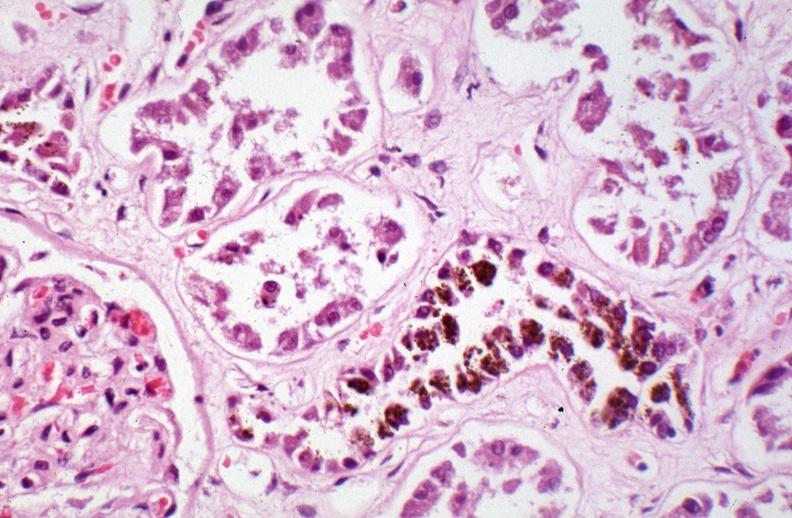s muscle caused by numerous blood transfusions?
Answer the question using a single word or phrase. No 